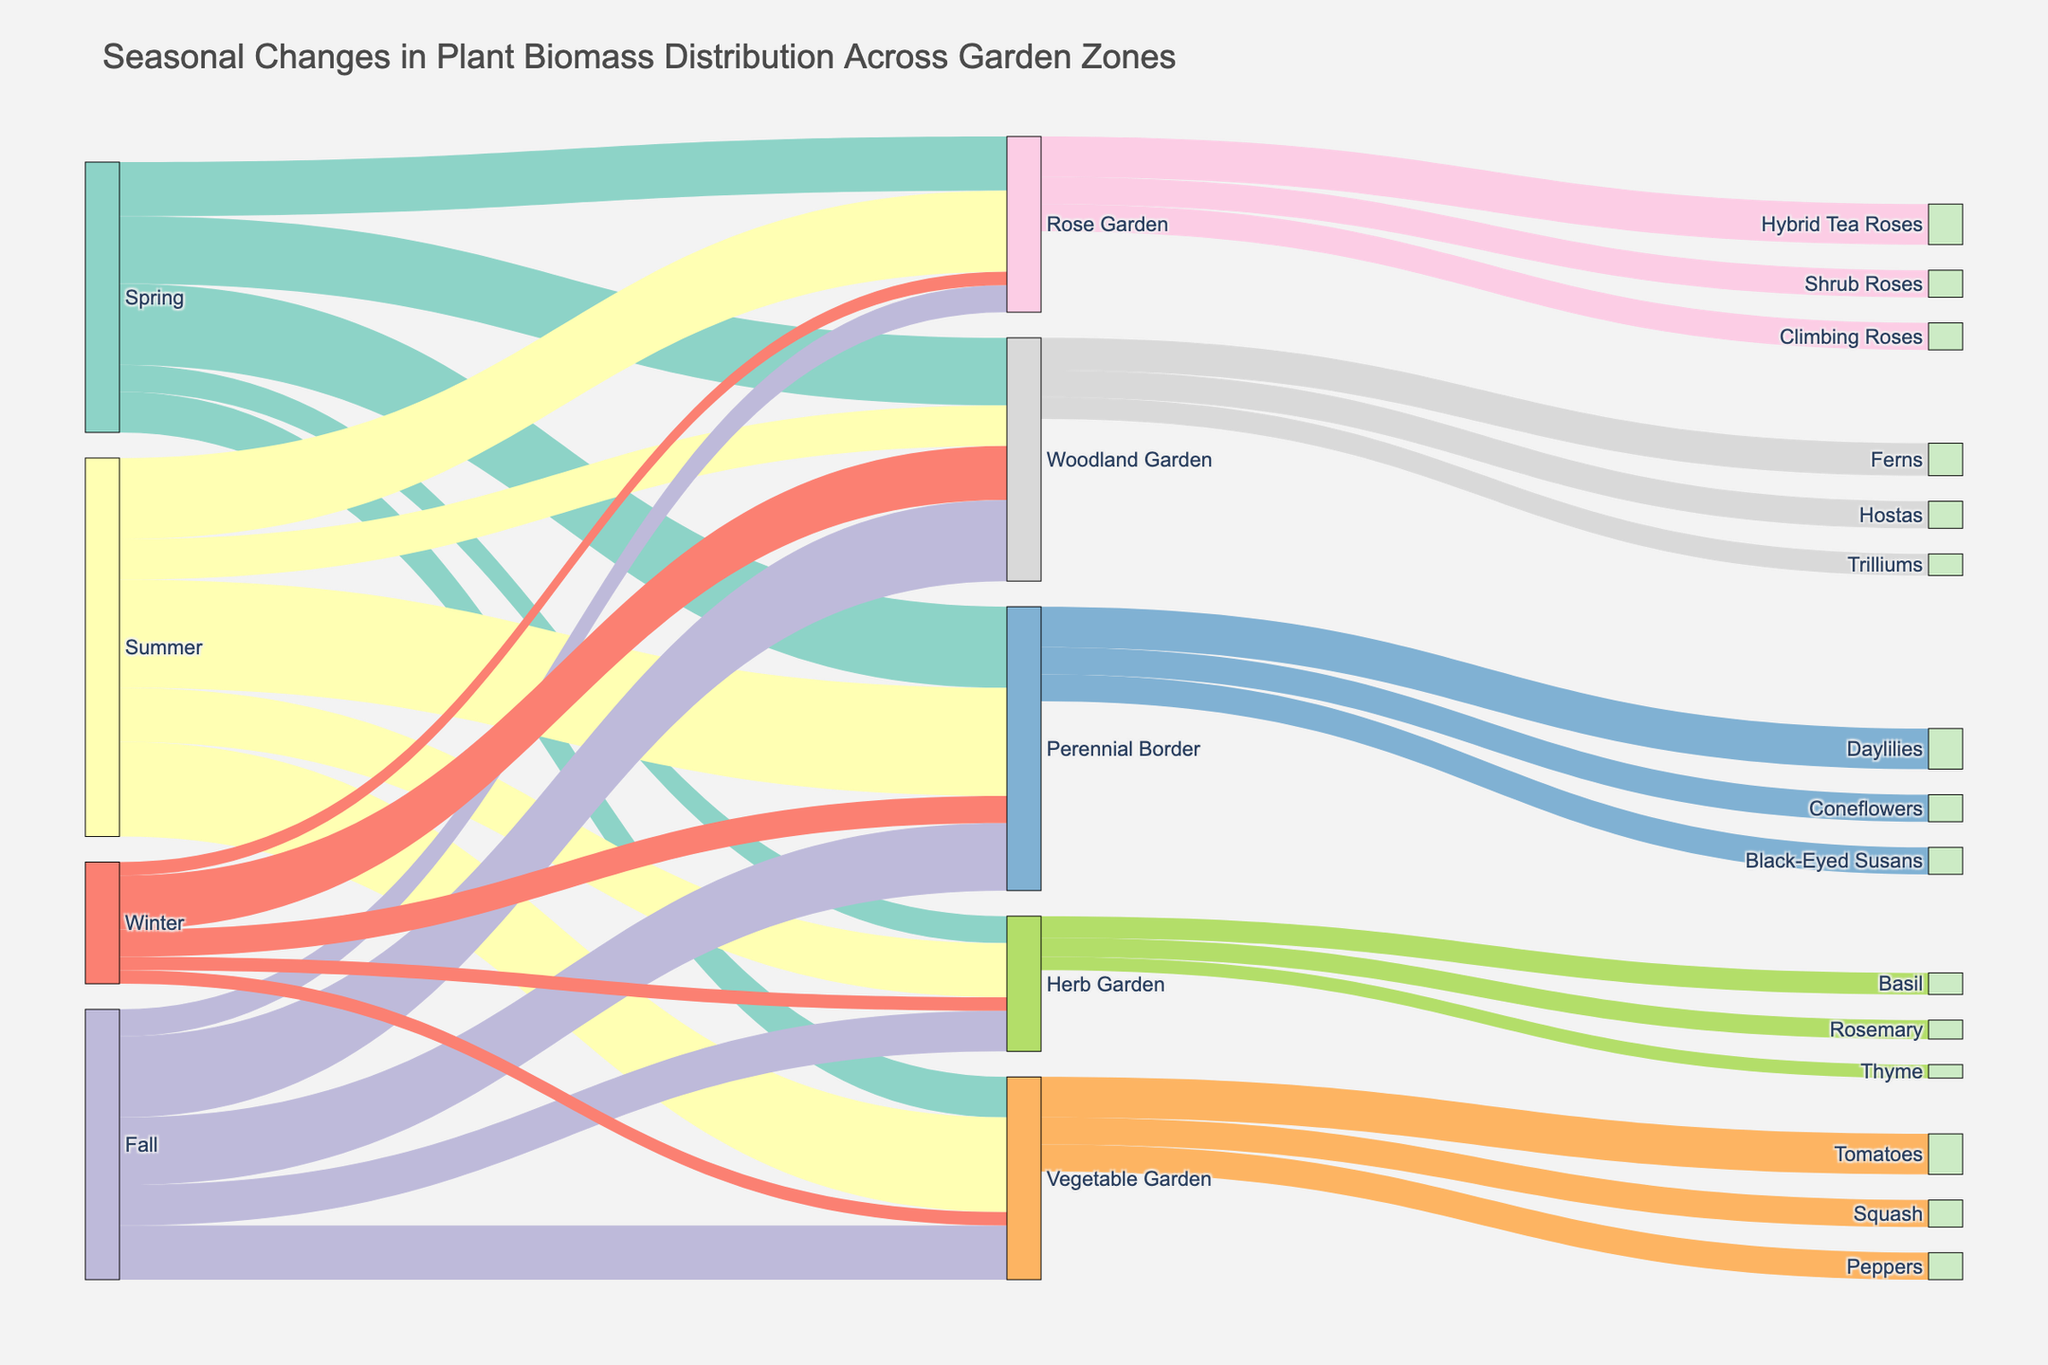What's the title of the figure? The title is usually displayed at the top of the figure. Looking at the Sankey Diagram, it shows the title "Seasonal Changes in Plant Biomass Distribution Across Garden Zones."
Answer: Seasonal Changes in Plant Biomass Distribution Across Garden Zones Which garden zone has the highest biomass value in Spring? In the Spring season, the Sankey Diagram shows five garden zones flowing from the 'Spring' node. By comparing these values, we see that the Woodland Garden has the highest value at 25.
Answer: Woodland Garden What are the biomass values for the Vegetable Garden across different seasons? To find the Vegetable Garden values, look at the links from each season node (Spring, Summer, Fall, and Winter) leading to the Vegetable Garden. The values are: Spring (15), Summer (35), Fall (20), and Winter (5).
Answer: 15 in Spring, 35 in Summer, 20 in Fall, 5 in Winter Which plant type has consistent biomass and appears in the Perennial Border through different seasons? Observing the Perennial Border, there are multiple plant types (Daylilies, Coneflowers, Black-Eyed Susans). To check for consistency, note their presence throughout different seasonal changes into the Perennial Border. All three appear consistently in this zone.
Answer: Daylilies, Coneflowers, Black-Eyed Susans How does the biomass distribution for the Woodland Garden change from Spring to Winter? By following the links from 'Spring' to 'Woodland Garden' and 'Winter' to 'Woodland Garden,' we see that the biomass changes from 25 in Spring to 20 in Winter.
Answer: Decreases from 25 to 20 Compare the biomass of the Perennial Border and Herb Garden in Summer. Which one is higher? From the Summer node, follow the links to Perennial Border and Herb Garden. The Perennial Border has a biomass of 40, and the Herb Garden has a biomass of 20. Clearly, the Perennial Border is higher.
Answer: Perennial Border What is the total biomass value for Rose Garden across all seasons? Sum the values for Rose Garden from each season: Spring (20), Summer (30), Fall (10), Winter (5). The total is 20 + 30 + 10 + 5.
Answer: 65 Which specific type of rose has a higher biomass value in the Rose Garden? From the Rose Garden node, observe the links to various rose types (Hybrid Tea Roses, Climbing Roses, Shrub Roses). The highest biomass value is for Hybrid Tea Roses at 15.
Answer: Hybrid Tea Roses During which season does the Perennial Border have the lowest biomass value? Look at the links leading to the Perennial Border from each season. The biomass values are: Spring (30), Summer (40), Fall (25), Winter (10). The lowest value is in Winter.
Answer: Winter What is the combined biomass value of the Herb Garden and Vegetable Garden in Fall? Add the biomass values for Herb Garden (15) and Vegetable Garden (20) in Fall: 15 + 20.
Answer: 35 